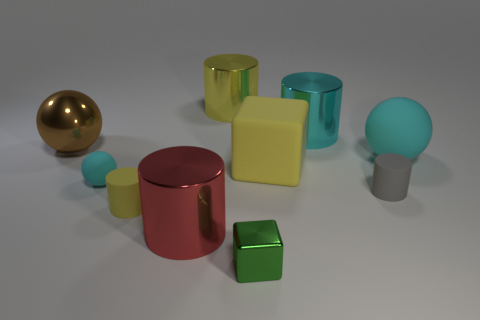Subtract all yellow metal cylinders. How many cylinders are left? 4 Subtract all cyan cylinders. How many cylinders are left? 4 Subtract all brown cylinders. Subtract all brown spheres. How many cylinders are left? 5 Subtract all cubes. How many objects are left? 8 Add 5 brown shiny balls. How many brown shiny balls exist? 6 Subtract 0 red spheres. How many objects are left? 10 Subtract all small cyan balls. Subtract all big yellow objects. How many objects are left? 7 Add 7 big brown metallic balls. How many big brown metallic balls are left? 8 